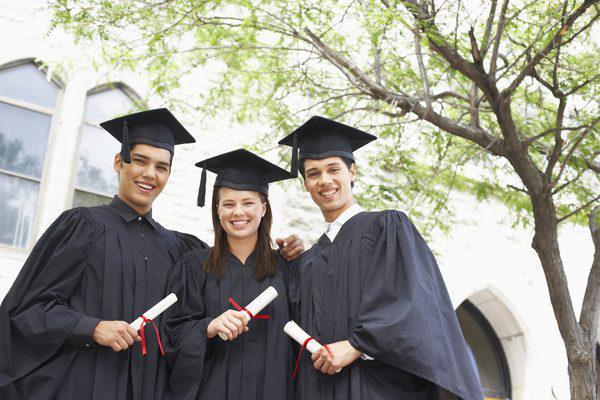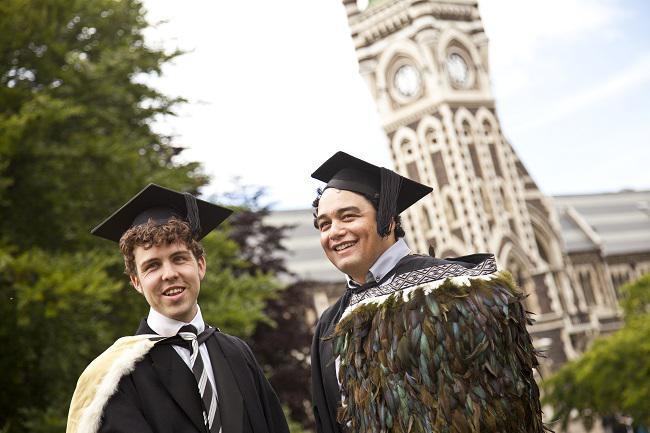The first image is the image on the left, the second image is the image on the right. Considering the images on both sides, is "There is a graduate with a flower necklace." valid? Answer yes or no. No. The first image is the image on the left, the second image is the image on the right. Given the left and right images, does the statement "There are 3 people in one of the photos." hold true? Answer yes or no. Yes. 